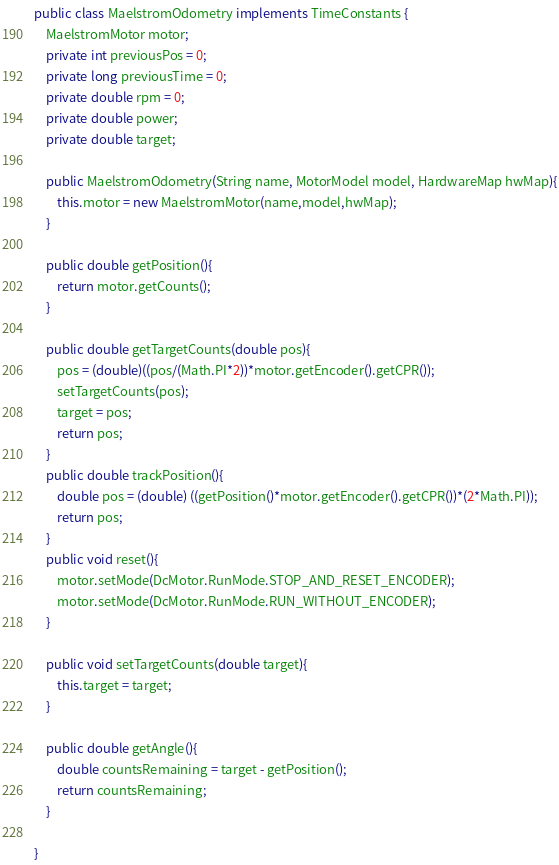<code> <loc_0><loc_0><loc_500><loc_500><_Java_>public class MaelstromOdometry implements TimeConstants {
    MaelstromMotor motor;
    private int previousPos = 0;
    private long previousTime = 0;
    private double rpm = 0;
    private double power;
    private double target;

    public MaelstromOdometry(String name, MotorModel model, HardwareMap hwMap){
        this.motor = new MaelstromMotor(name,model,hwMap);
    }

    public double getPosition(){
        return motor.getCounts();
    }

    public double getTargetCounts(double pos){
        pos = (double)((pos/(Math.PI*2))*motor.getEncoder().getCPR());
        setTargetCounts(pos);
        target = pos;
        return pos;
    }
    public double trackPosition(){
        double pos = (double) ((getPosition()*motor.getEncoder().getCPR())*(2*Math.PI));
        return pos;
    }
    public void reset(){
        motor.setMode(DcMotor.RunMode.STOP_AND_RESET_ENCODER);
        motor.setMode(DcMotor.RunMode.RUN_WITHOUT_ENCODER);
    }

    public void setTargetCounts(double target){
        this.target = target;
    }

    public double getAngle(){
        double countsRemaining = target - getPosition();
        return countsRemaining;
    }

}
</code> 